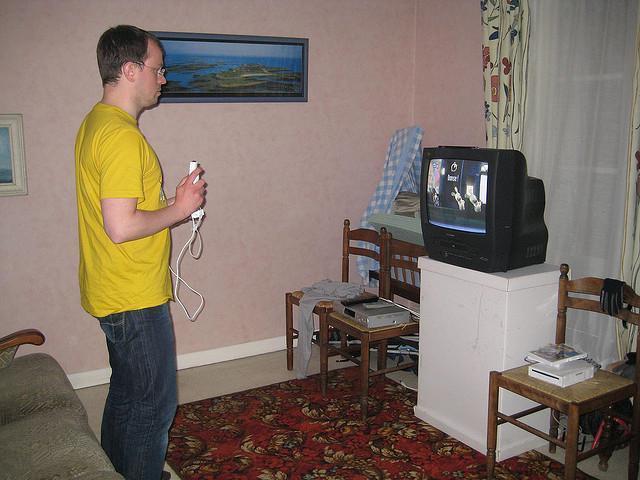How many chairs are there?
Give a very brief answer. 3. 